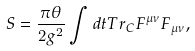<formula> <loc_0><loc_0><loc_500><loc_500>S = \frac { \pi \theta } { 2 g ^ { 2 } } \int d t T r _ { C } F ^ { \mu \nu } F _ { \mu \nu } ,</formula> 